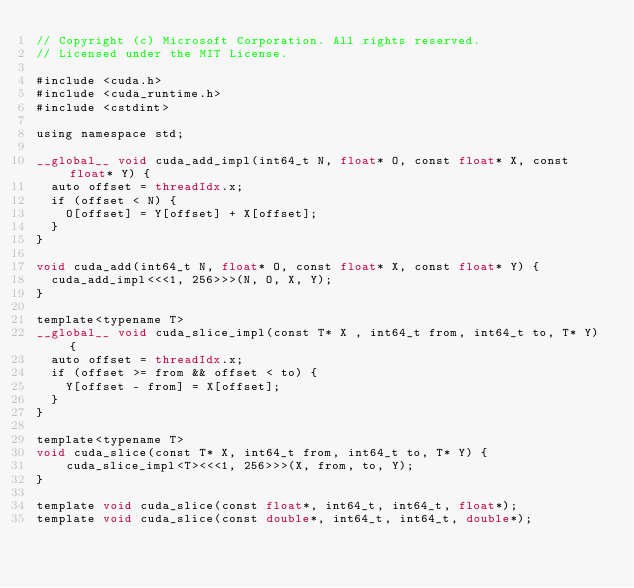<code> <loc_0><loc_0><loc_500><loc_500><_Cuda_>// Copyright (c) Microsoft Corporation. All rights reserved.
// Licensed under the MIT License.

#include <cuda.h>
#include <cuda_runtime.h>
#include <cstdint>

using namespace std;

__global__ void cuda_add_impl(int64_t N, float* O, const float* X, const float* Y) {
  auto offset = threadIdx.x;
  if (offset < N) {
    O[offset] = Y[offset] + X[offset];
  }
}

void cuda_add(int64_t N, float* O, const float* X, const float* Y) {
  cuda_add_impl<<<1, 256>>>(N, O, X, Y);
}

template<typename T>
__global__ void cuda_slice_impl(const T* X , int64_t from, int64_t to, T* Y) {
  auto offset = threadIdx.x;
  if (offset >= from && offset < to) {
    Y[offset - from] = X[offset];
  }
}

template<typename T>
void cuda_slice(const T* X, int64_t from, int64_t to, T* Y) {
    cuda_slice_impl<T><<<1, 256>>>(X, from, to, Y);
}

template void cuda_slice(const float*, int64_t, int64_t, float*);
template void cuda_slice(const double*, int64_t, int64_t, double*);
</code> 